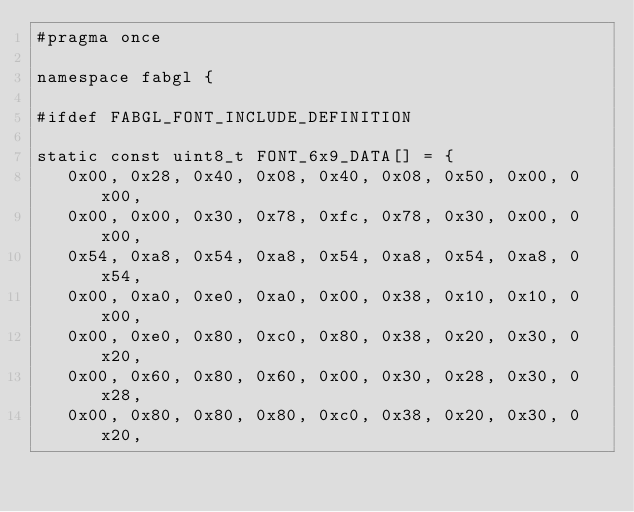Convert code to text. <code><loc_0><loc_0><loc_500><loc_500><_C_>#pragma once

namespace fabgl {

#ifdef FABGL_FONT_INCLUDE_DEFINITION

static const uint8_t FONT_6x9_DATA[] = {
   0x00, 0x28, 0x40, 0x08, 0x40, 0x08, 0x50, 0x00, 0x00,
   0x00, 0x00, 0x30, 0x78, 0xfc, 0x78, 0x30, 0x00, 0x00,
   0x54, 0xa8, 0x54, 0xa8, 0x54, 0xa8, 0x54, 0xa8, 0x54,
   0x00, 0xa0, 0xe0, 0xa0, 0x00, 0x38, 0x10, 0x10, 0x00,
   0x00, 0xe0, 0x80, 0xc0, 0x80, 0x38, 0x20, 0x30, 0x20,
   0x00, 0x60, 0x80, 0x60, 0x00, 0x30, 0x28, 0x30, 0x28,
   0x00, 0x80, 0x80, 0x80, 0xc0, 0x38, 0x20, 0x30, 0x20,</code> 